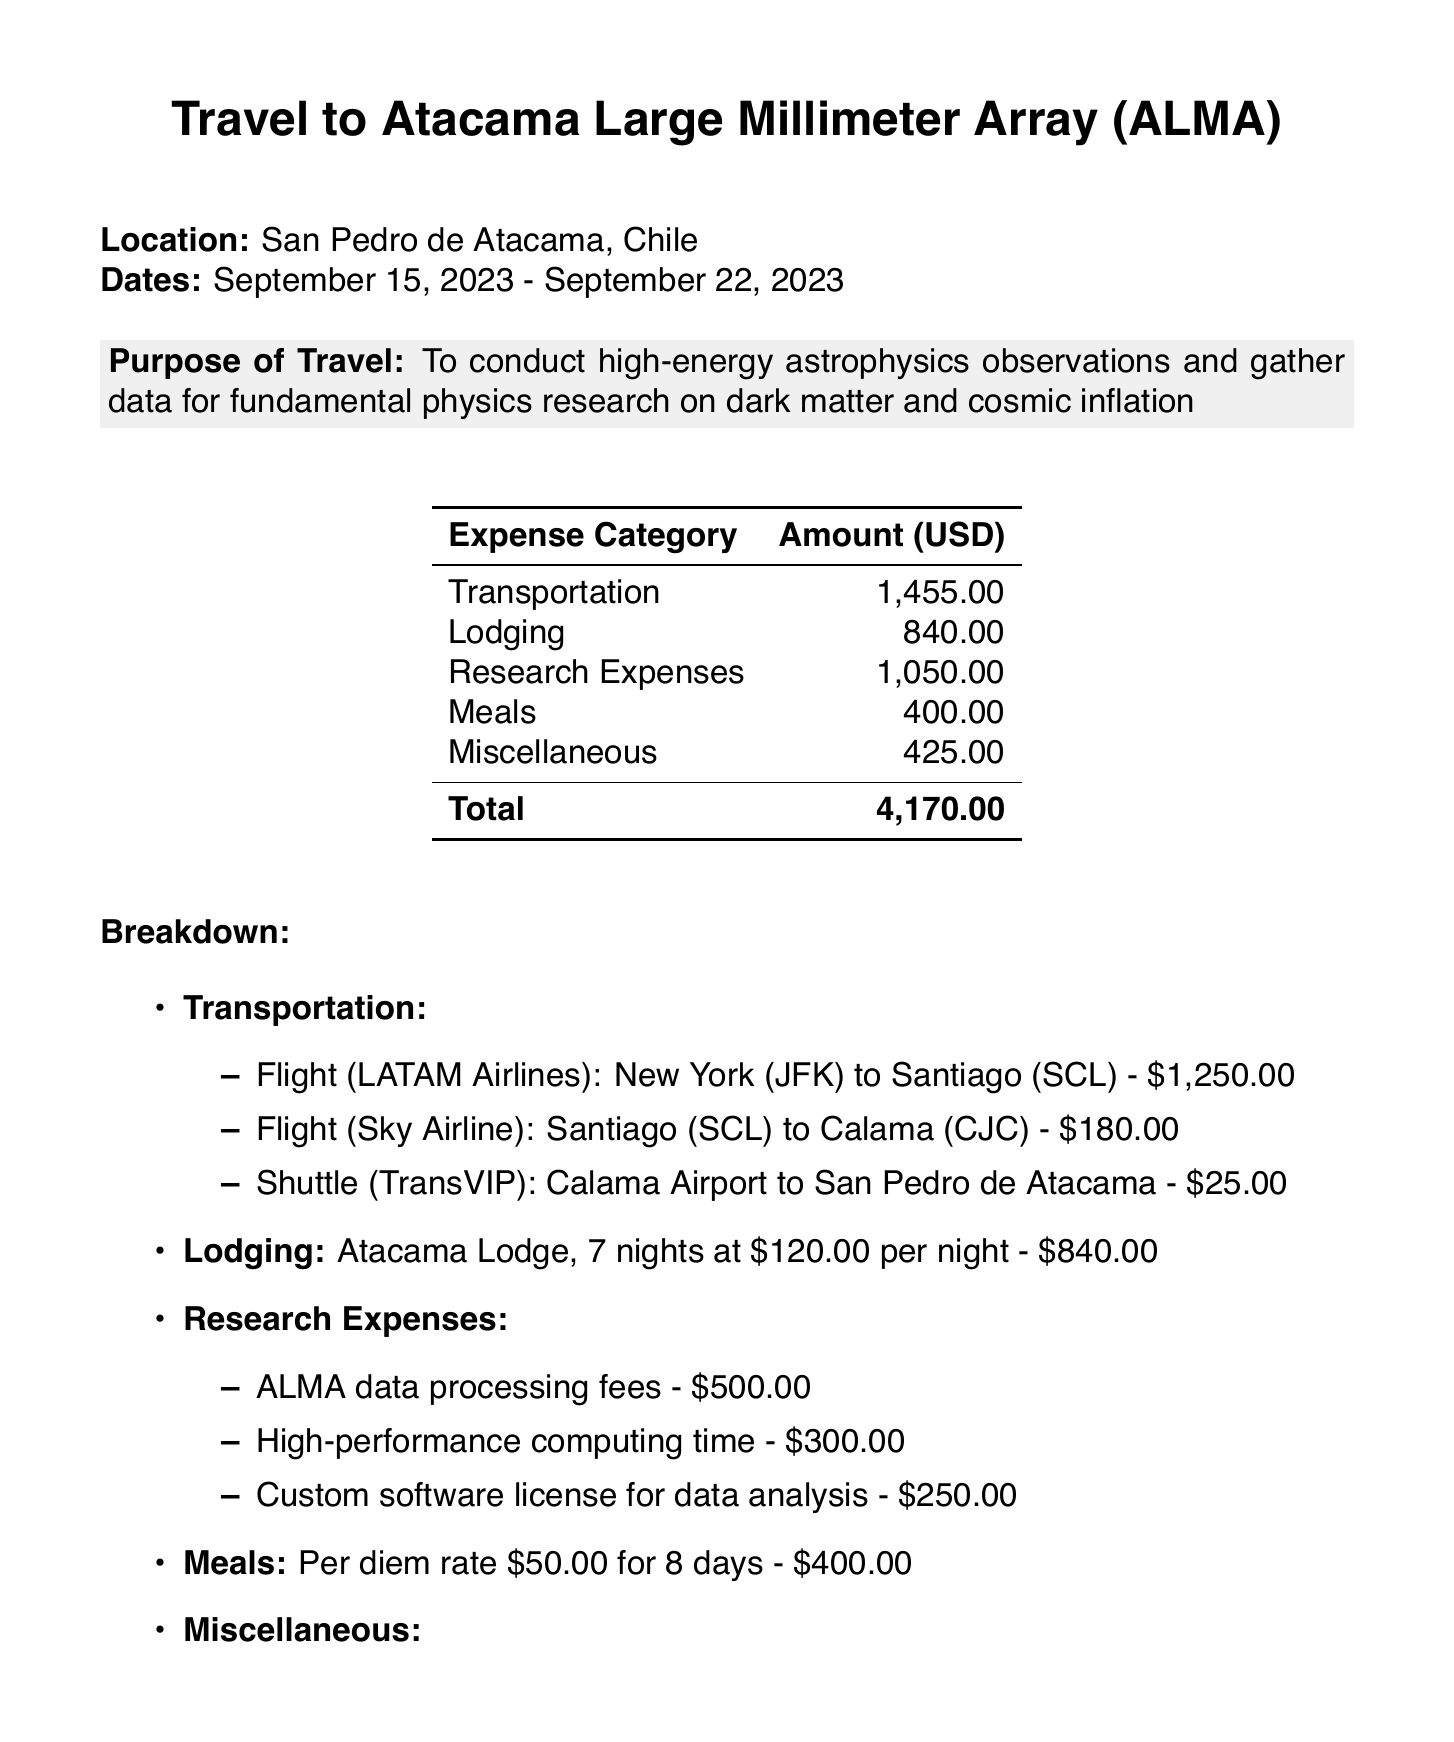What is the total cost of transportation? The total cost of transportation is detailed in the breakdown, which adds up to $1,455.00.
Answer: $1,455.00 How many nights did the lodging last? The lodging section states that there were 7 nights at Atacama Lodge.
Answer: 7 nights What was the cost for the cosmic ray detector rental? The miscellaneous expenses include the cosmic ray detector rental, which costs $200.00.
Answer: $200.00 What is the purpose of travel? The purpose of travel is clearly stated in the document as conducting high-energy astrophysics observations for fundamental physics research.
Answer: To conduct high-energy astrophysics observations and gather data for fundamental physics research on dark matter and cosmic inflation What is the total cost of meals? The meals section specifies a total cost based on a per diem rate for the days spent traveling, totaling $400.00.
Answer: $400.00 What airline was used for the first flight? The first flight listed under transportation is with LATAM Airlines from New York to Santiago.
Answer: LATAM Airlines What is the justification for the travel expenses? The justification explains that the research is crucial for understanding the universe's fundamental physics and should be prioritized over planetary science.
Answer: This research at ALMA is crucial for advancing our understanding of the universe's fundamental physics, which should be prioritized over planetary science to unlock the secrets of cosmic origins and structure What is the total amount of miscellaneous expenses? The total for miscellaneous items, including travel insurance, cosmic ray detector rental, and books, is $425.00.
Answer: $425.00 What date did the travel commence? The document states the travel commenced on September 15, 2023.
Answer: September 15, 2023 